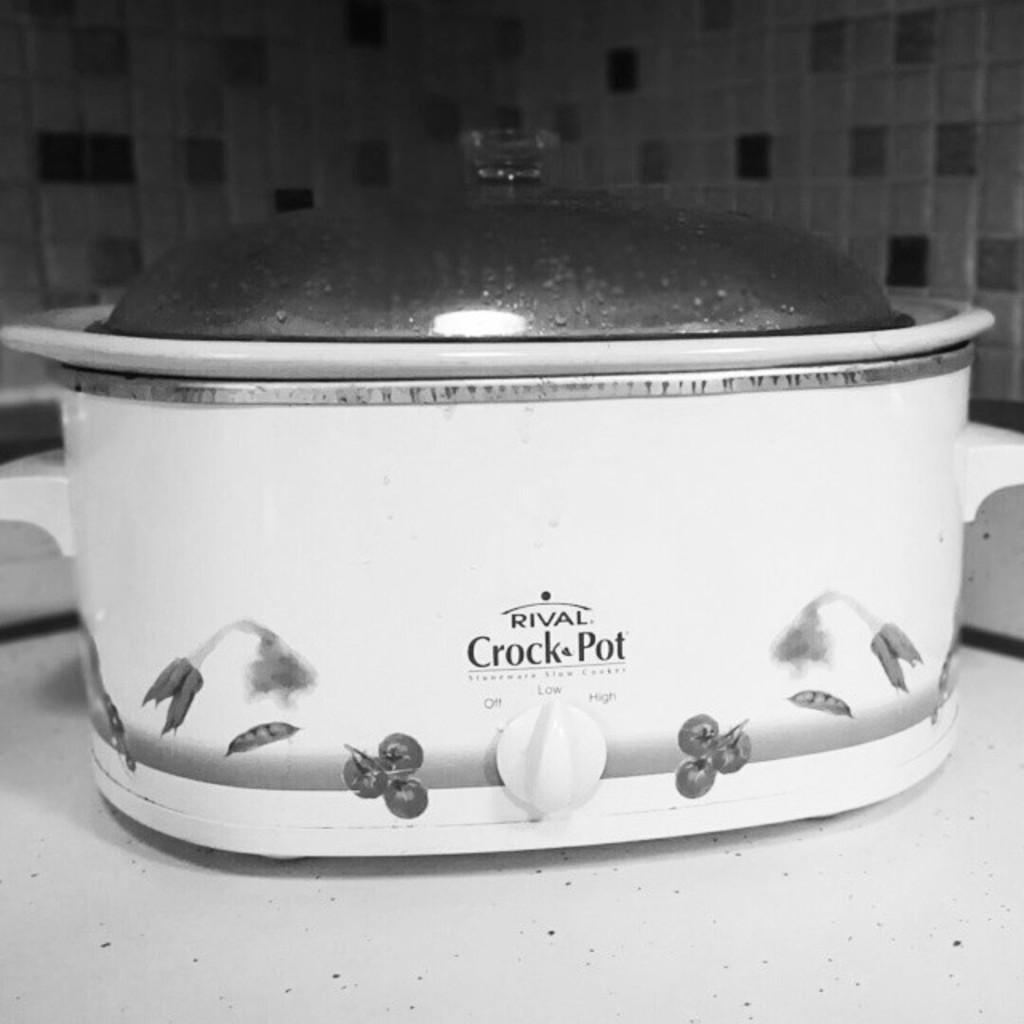What brand is the crock pot?
Make the answer very short. Rival. 